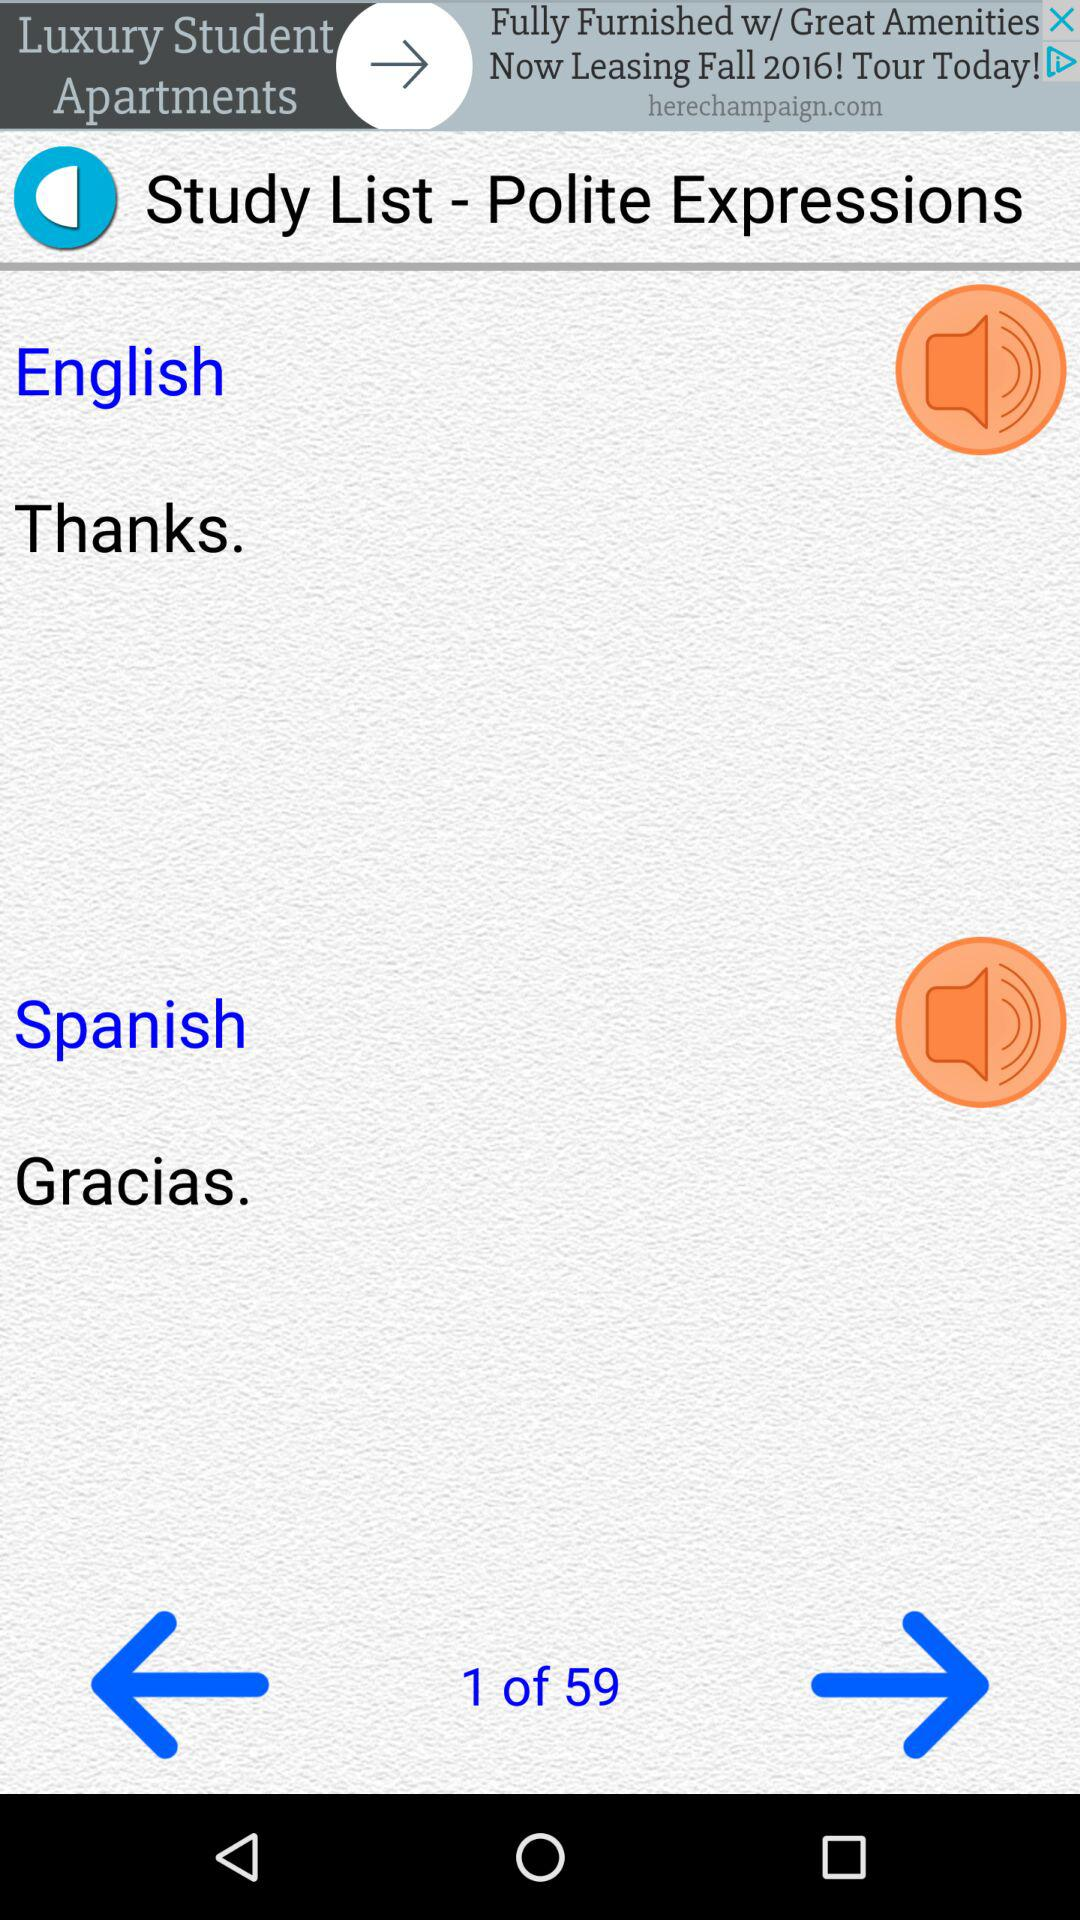How many total pages are there? There are 59 pages. 